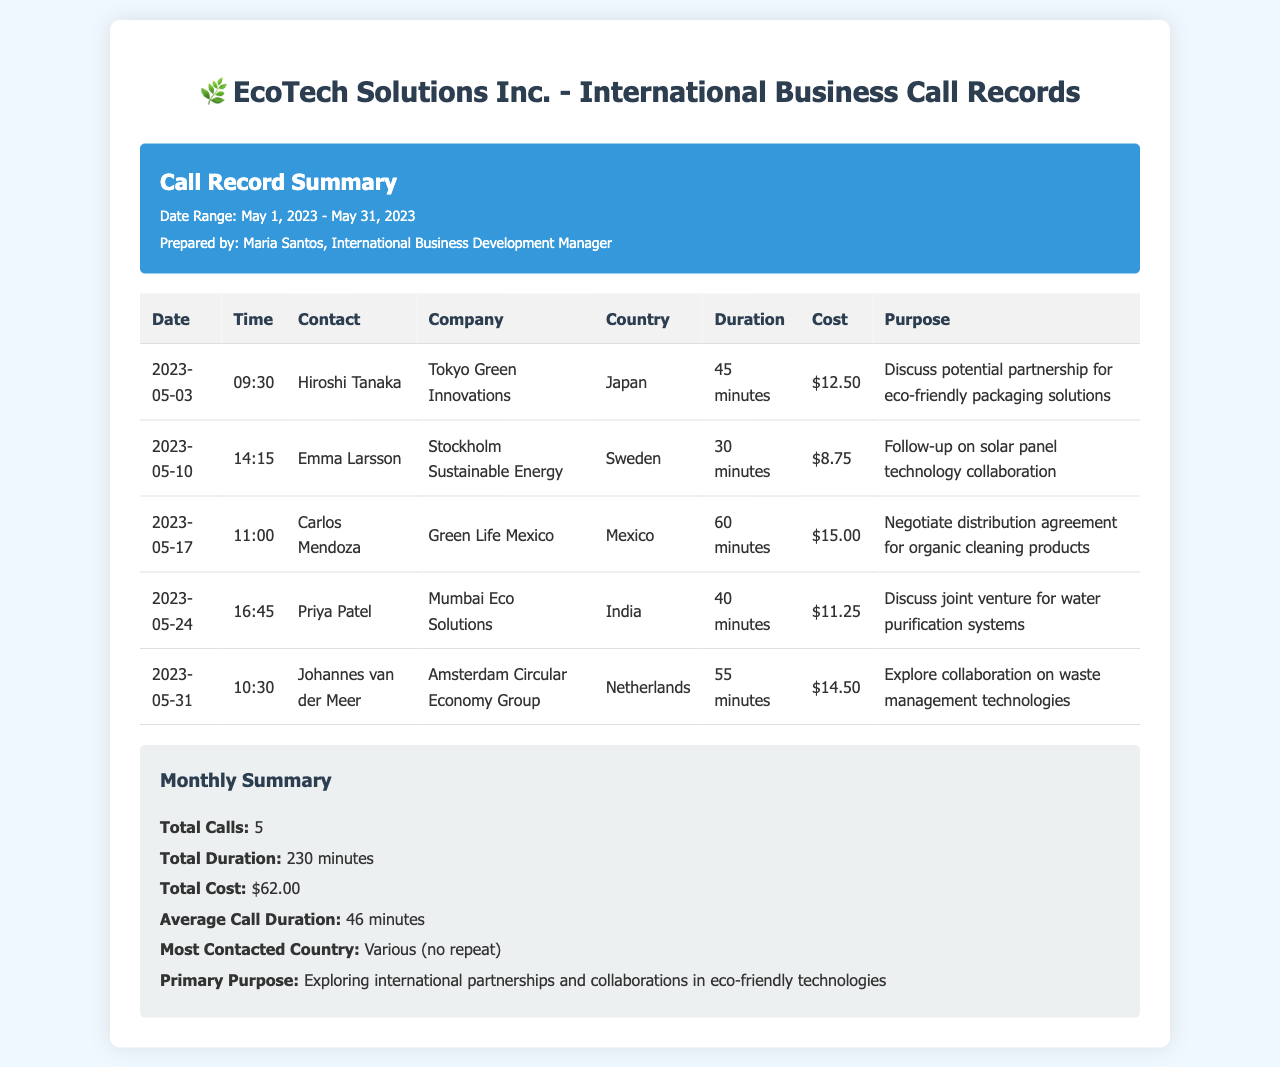What is the total cost of all calls? The total cost is calculated by adding all the individual call costs listed in the document: $12.50 + $8.75 + $15.00 + $11.25 + $14.50 = $62.00.
Answer: $62.00 Who is the contact for the call on May 10, 2023? The contact for the call on that date is Emma Larsson.
Answer: Emma Larsson How long was the call with Hiroshi Tanaka? The duration of the call with Hiroshi Tanaka is specified as 45 minutes.
Answer: 45 minutes What was the primary purpose of the calls? The primary purpose described in the summary is to explore international partnerships and collaborations in eco-friendly technologies.
Answer: Exploring international partnerships and collaborations in eco-friendly technologies Which country was contacted on May 24, 2023? The country contacted on that date is India.
Answer: India What is the average call duration? The average call duration is calculated based on the total duration divided by the number of calls: 230 minutes / 5 calls = 46 minutes.
Answer: 46 minutes Which company did Carlos Mendoza represent? The company associated with Carlos Mendoza in the records is Green Life Mexico.
Answer: Green Life Mexico How many calls were made in total? The document specifies that a total of 5 calls were made.
Answer: 5 What is the contact's name for the last call in May? The contact's name for the last call is Johannes van der Meer.
Answer: Johannes van der Meer 